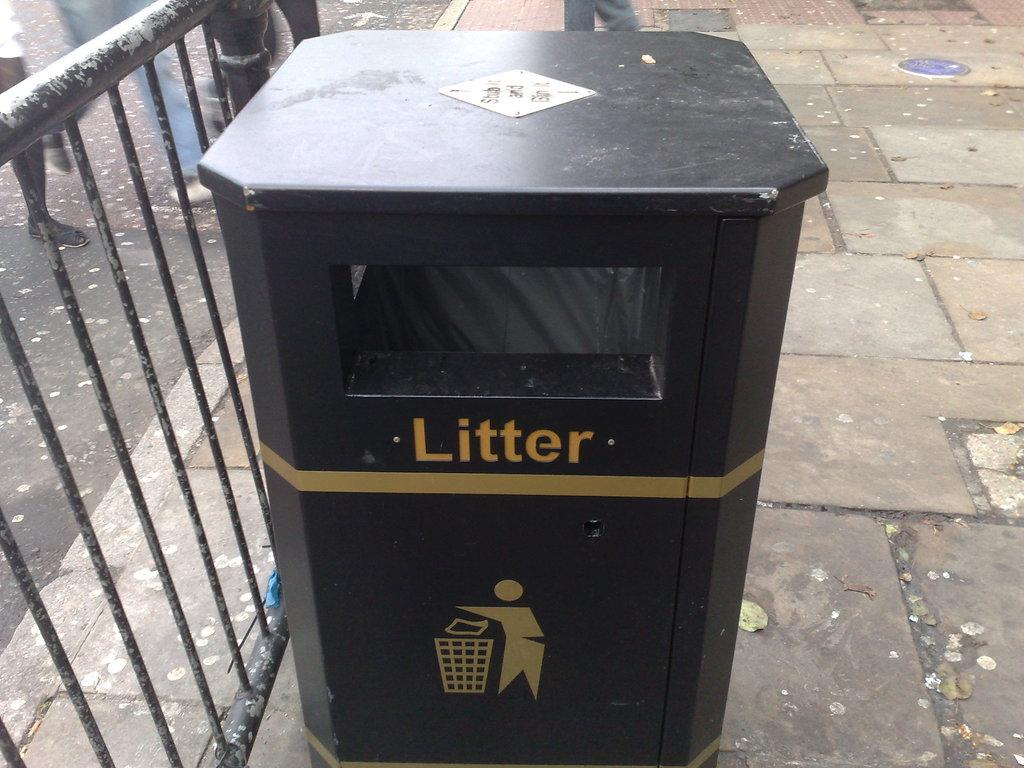Provide a one-sentence caption for the provided image. A black trash can has the word Litter painted on it with an image of a person throwing away their trash. 